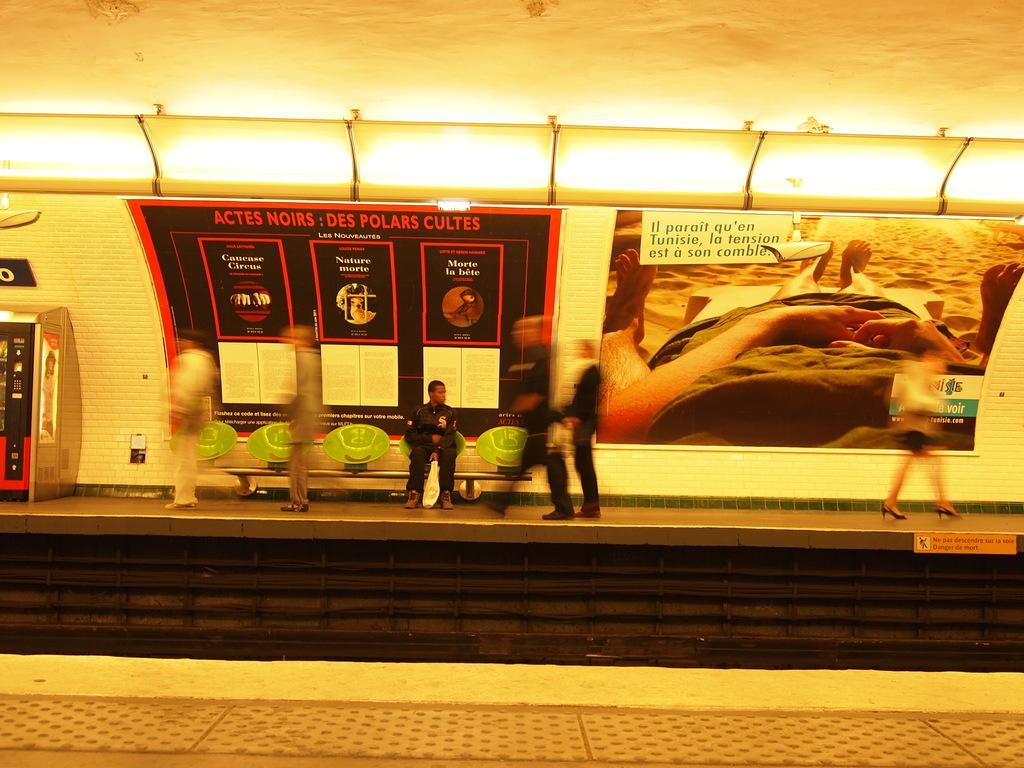In one or two sentences, can you explain what this image depicts? This image is clicked in a railway station, there are platforms on either side with a track in the middle and people walking in the back platform and a person sitting on chair and there are lights over the ceiling with ad banners below it. 